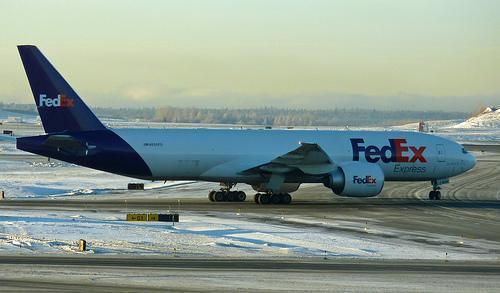How many planes?
Give a very brief answer. 1. 